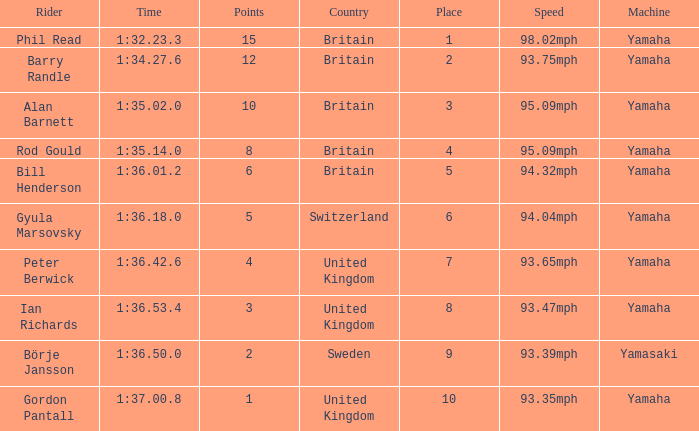What was the time for the man who scored 1 point? 1:37.00.8. 